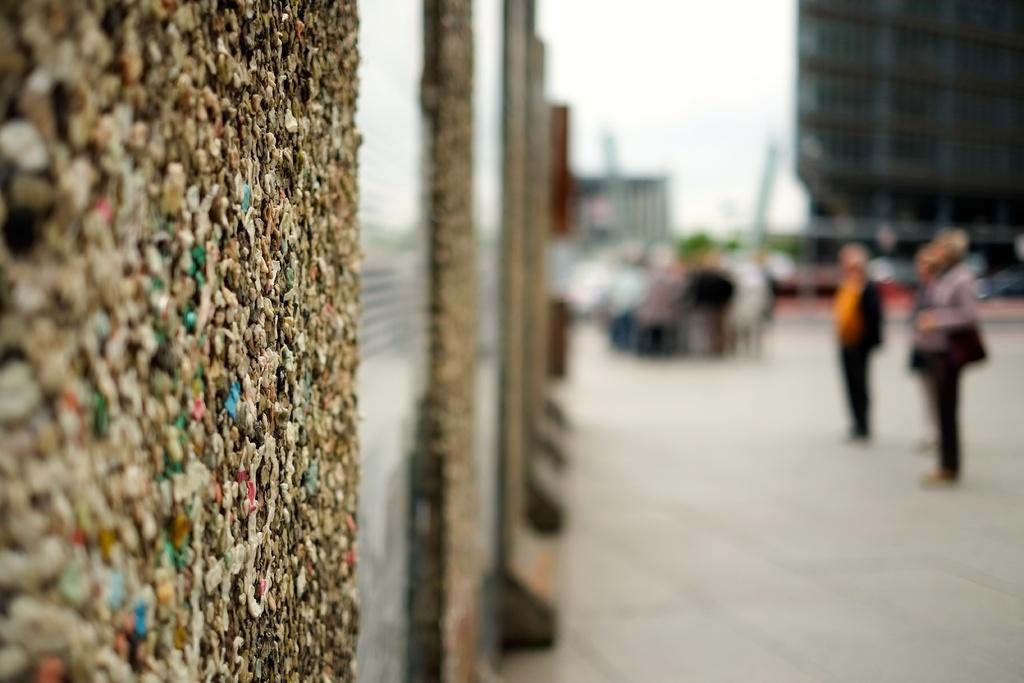What type of structure can be seen in the image? There is a wall in the image. What are the people in the image doing? There is a group of people on the ground in the image. What else can be seen in the image besides the wall and people? There is a building in the image. What is visible in the background of the image? The sky is visible in the image. How many cars are parked on the wall in the image? There are no cars present in the image, as it features a wall, a group of people, a building, and the sky. What type of bird can be seen flying near the building in the image? There is no bird visible in the image; it only features a wall, a group of people, a building, and the sky. 